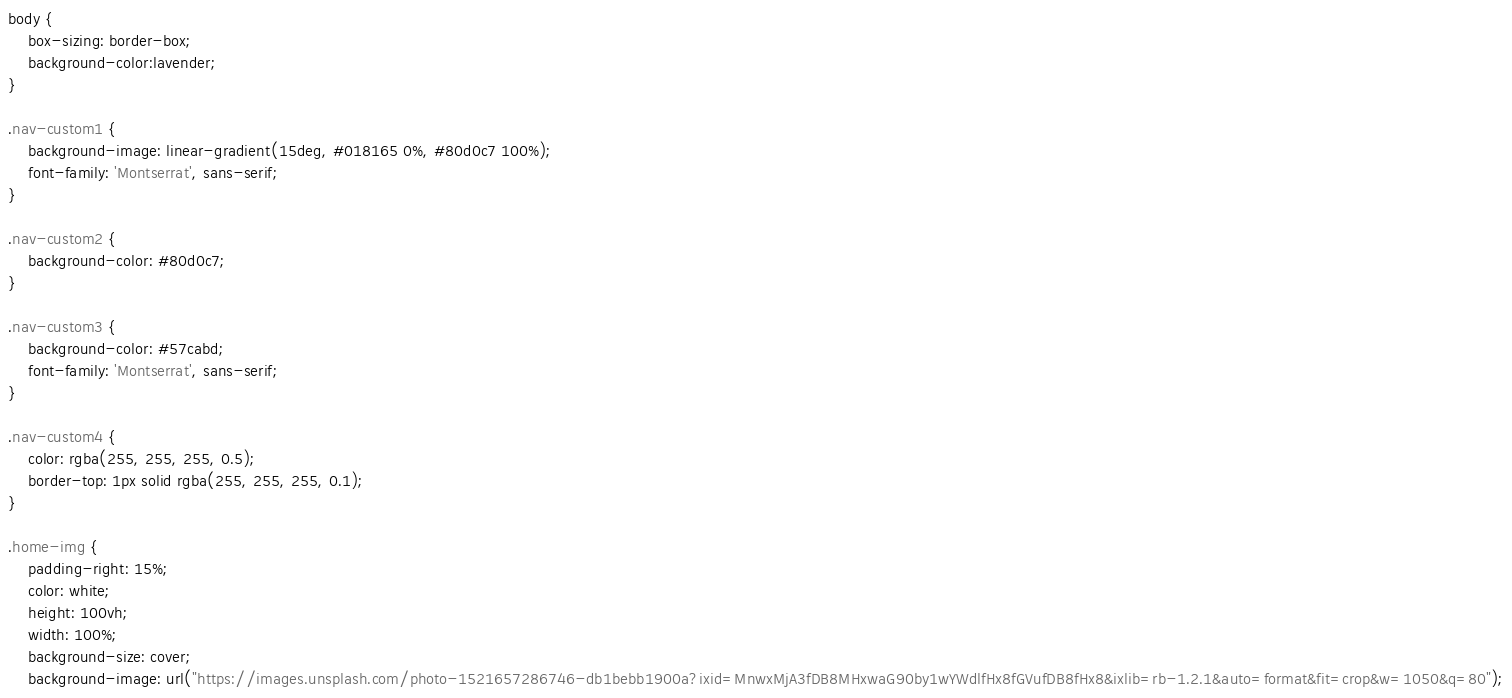<code> <loc_0><loc_0><loc_500><loc_500><_CSS_>body {
    box-sizing: border-box;
    background-color:lavender;
}

.nav-custom1 {
    background-image: linear-gradient(15deg, #018165 0%, #80d0c7 100%);
    font-family: 'Montserrat', sans-serif;
}

.nav-custom2 {
    background-color: #80d0c7;
}

.nav-custom3 {
    background-color: #57cabd;
    font-family: 'Montserrat', sans-serif;
}

.nav-custom4 {
    color: rgba(255, 255, 255, 0.5);
    border-top: 1px solid rgba(255, 255, 255, 0.1);
}

.home-img {
    padding-right: 15%;
    color: white;
    height: 100vh;
    width: 100%;
    background-size: cover;
    background-image: url("https://images.unsplash.com/photo-1521657286746-db1bebb1900a?ixid=MnwxMjA3fDB8MHxwaG90by1wYWdlfHx8fGVufDB8fHx8&ixlib=rb-1.2.1&auto=format&fit=crop&w=1050&q=80");</code> 